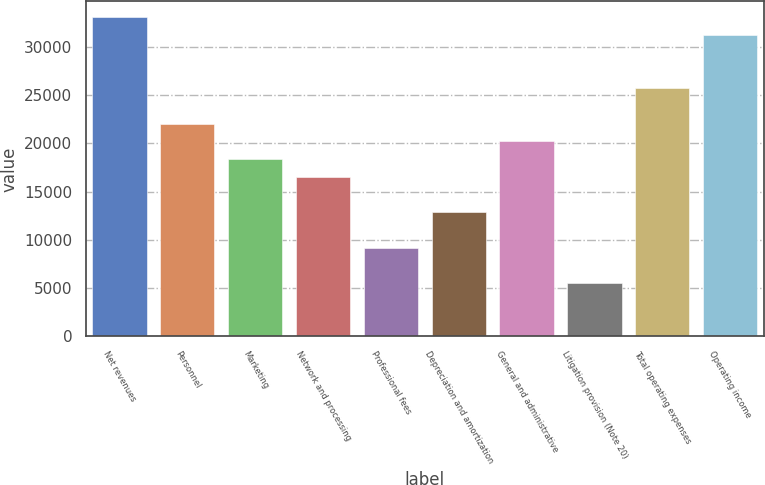Convert chart to OTSL. <chart><loc_0><loc_0><loc_500><loc_500><bar_chart><fcel>Net revenues<fcel>Personnel<fcel>Marketing<fcel>Network and processing<fcel>Professional fees<fcel>Depreciation and amortization<fcel>General and administrative<fcel>Litigation provision (Note 20)<fcel>Total operating expenses<fcel>Operating income<nl><fcel>33042.2<fcel>22029<fcel>18358<fcel>16522.5<fcel>9180.4<fcel>12851.4<fcel>20193.5<fcel>5509.36<fcel>25700.1<fcel>31206.6<nl></chart> 